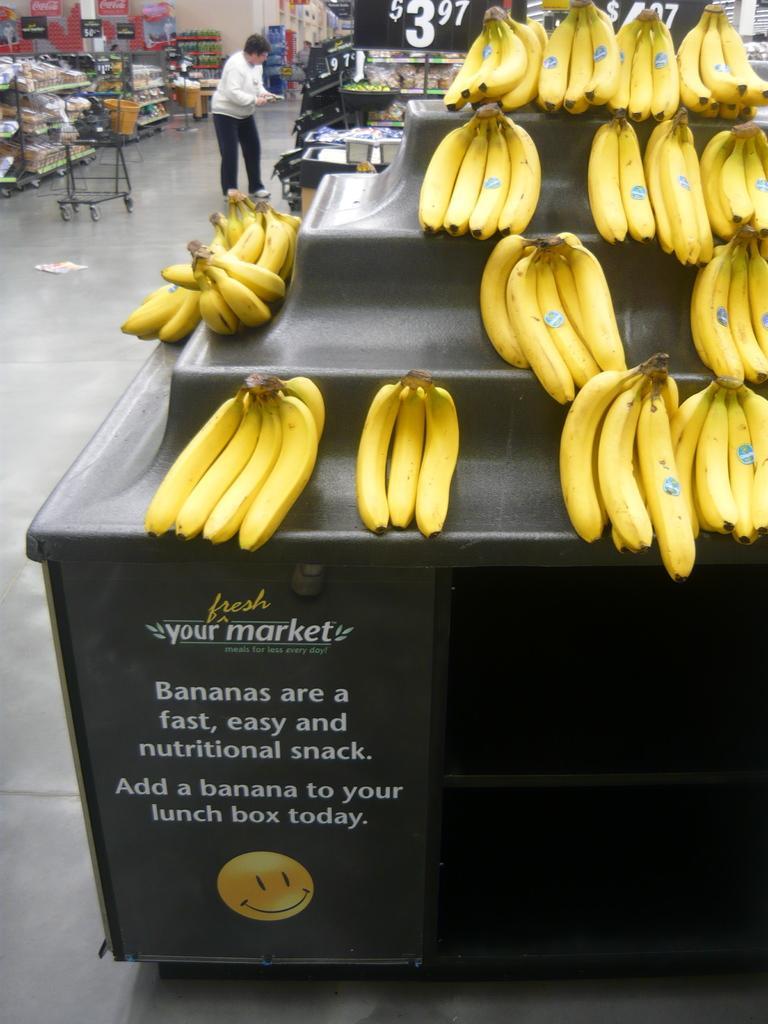Describe this image in one or two sentences. On this black table we can see bananas with stickers. Something written on this black table. Background we can see cart, racks, person, price tags and hoardings. In these racks there are things. 